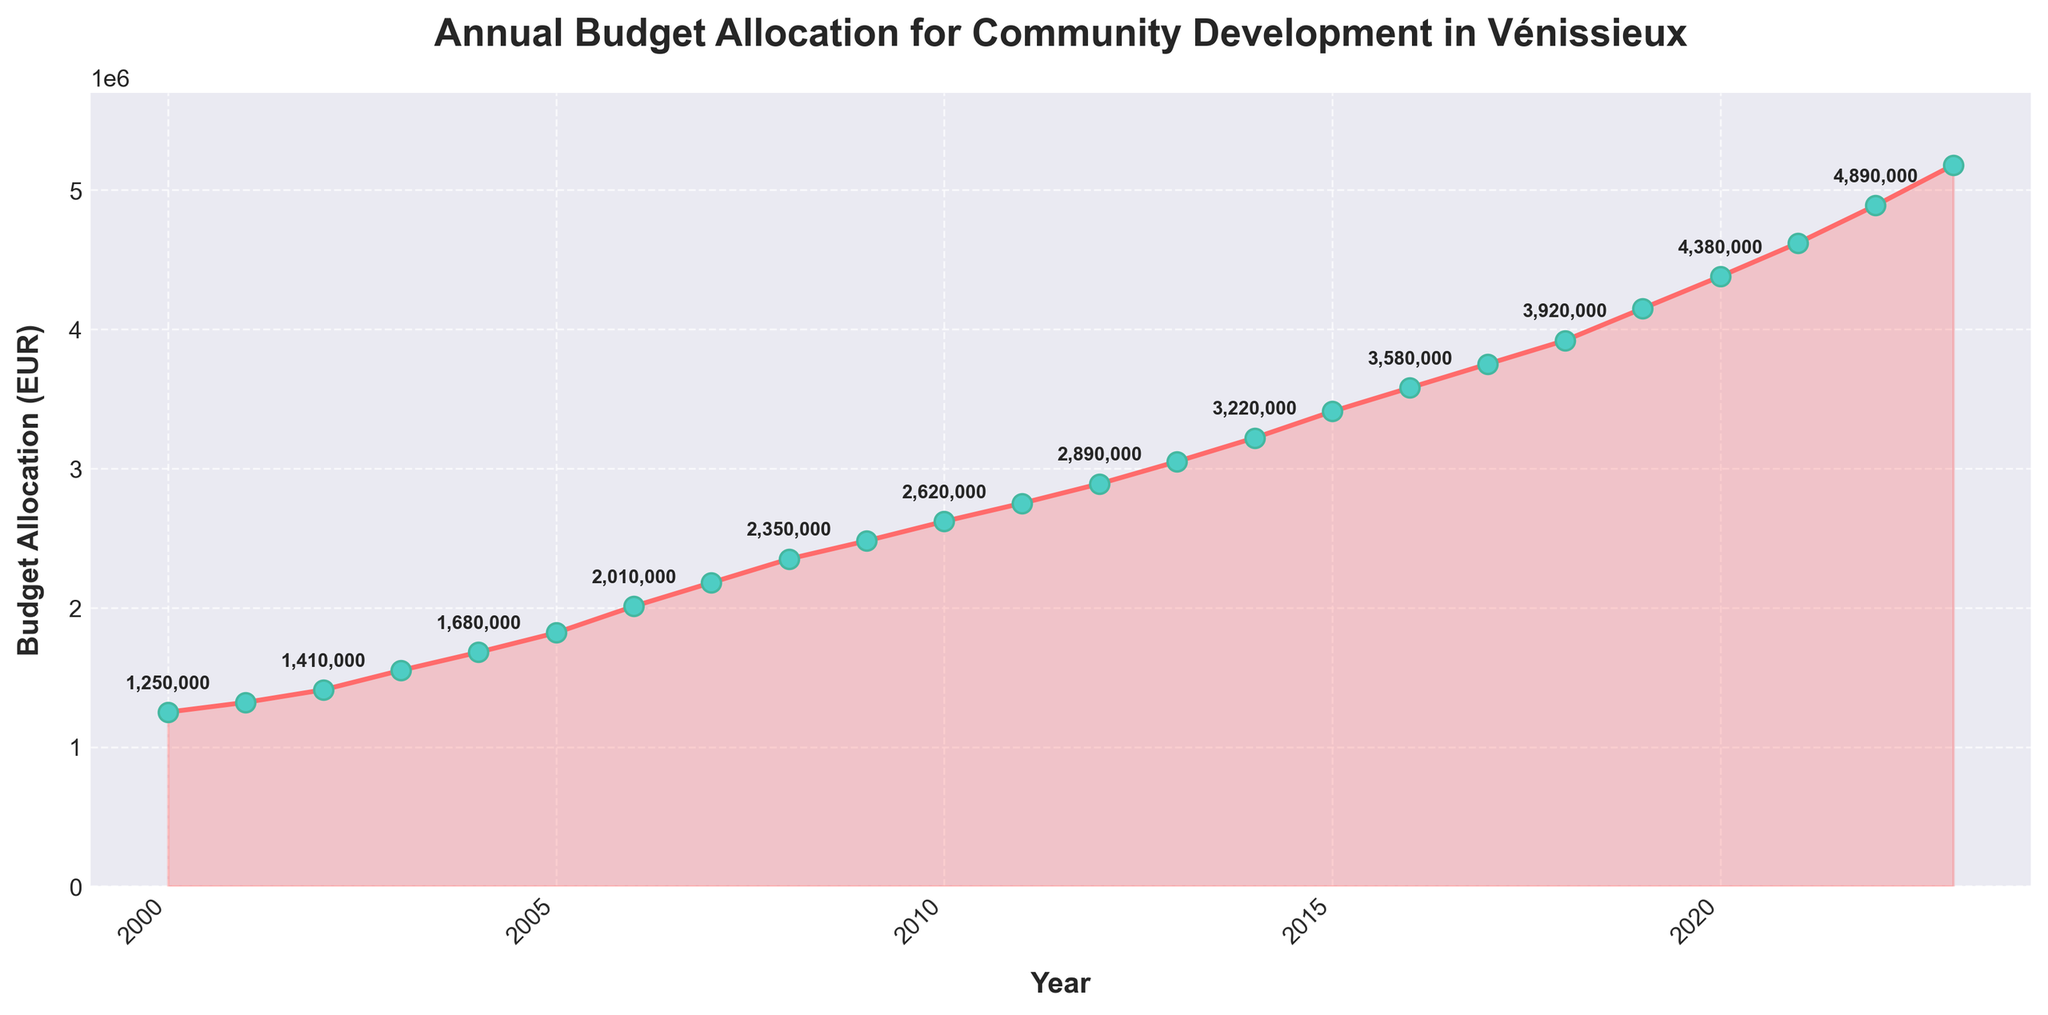What was the budget allocation in 2010? Look at the point corresponding to the year 2010 on the x-axis and read the y-axis value which represents the budget allocation.
Answer: 2,620,000 EUR What is the total budget allocated from 2000 to 2005? Sum the budget allocations for each year from 2000 to 2005: 1,250,000 + 1,320,000 + 1,410,000 + 1,550,000 + 1,680,000 + 1,820,000.
Answer: 9,030,000 EUR Between which two consecutive years did the budget allocation increase the most? Compare the differences in budget allocation between each pair of consecutive years and find the maximum increase.
Answer: 2022 and 2023 What is the average annual budget allocation from 2018 to 2023? Sum the budget allocations for each year from 2018 to 2023 and then divide by the number of years: (3,920,000 + 4,150,000 + 4,380,000 + 4,620,000 + 4,890,000 + 5,180,000) / 6.
Answer: 4,523,333 EUR Which year had a budget allocation of approximately 2,890,000 EUR? Look for the point on the line chart that corresponds to a budget allocation of approximately 2,890,000 EUR and note the corresponding year on the x-axis.
Answer: 2012 How much did the budget allocation increase from 2008 to 2009? Subtract the budget allocation in 2008 from the budget allocation in 2009: 2,480,000 - 2,350,000.
Answer: 130,000 EUR Which year had the smallest budget allocation and how much was it? Identify the lowest point on the line chart and read its value on the y-axis as well as the corresponding year on the x-axis.
Answer: 2000, 1,250,000 EUR By what factor did the budget allocation grow from 2000 to 2023? Divide the budget allocation in 2023 by the budget allocation in 2000: 5,180,000 / 1,250,000.
Answer: 4.14 What general trend can be observed in the budget allocation over the years? Observe the overall shape of the line chart to determine if it generally increases, decreases, or remains constant.
Answer: Increasing Between which years did the budget allocation remain constant without any increase or decrease? Look for a flat segment in the line chart where the budget allocation did not change between two consecutive years.
Answer: No such segment, always increasing 